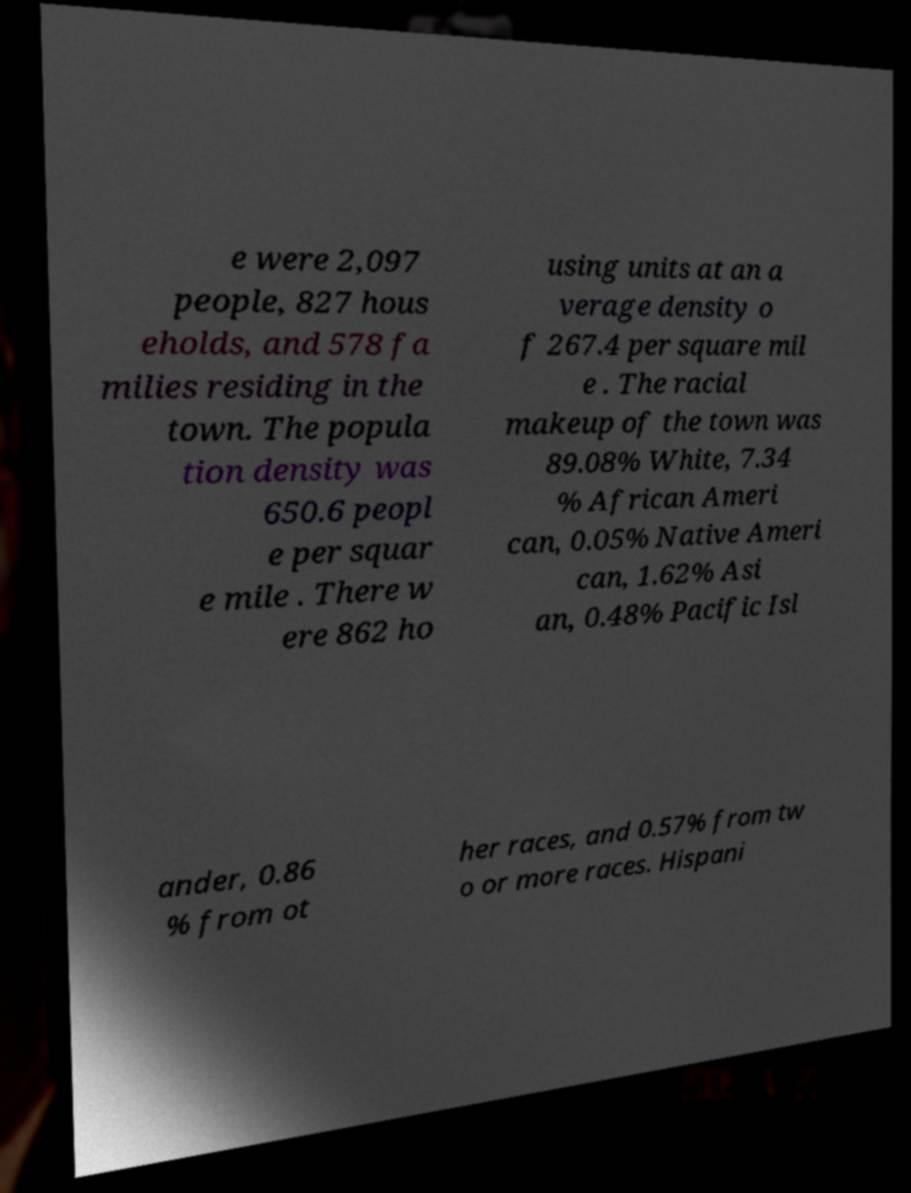Can you read and provide the text displayed in the image?This photo seems to have some interesting text. Can you extract and type it out for me? e were 2,097 people, 827 hous eholds, and 578 fa milies residing in the town. The popula tion density was 650.6 peopl e per squar e mile . There w ere 862 ho using units at an a verage density o f 267.4 per square mil e . The racial makeup of the town was 89.08% White, 7.34 % African Ameri can, 0.05% Native Ameri can, 1.62% Asi an, 0.48% Pacific Isl ander, 0.86 % from ot her races, and 0.57% from tw o or more races. Hispani 